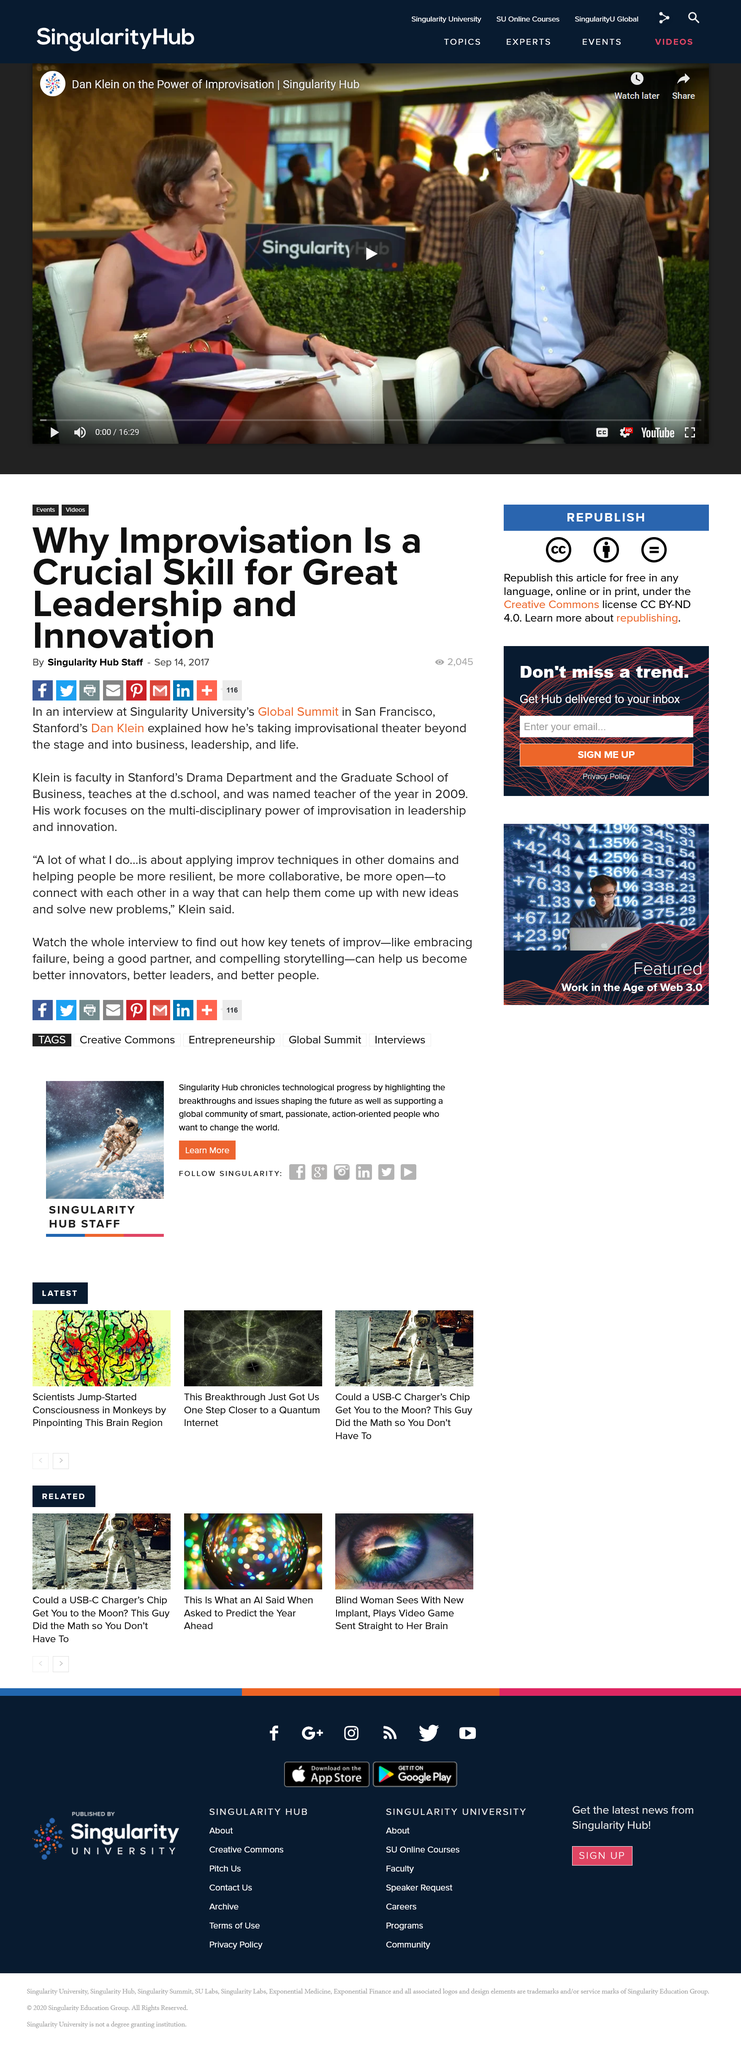Specify some key components in this picture. Dan Klein works in both the Drama Department and the Graduate School of Business at Stanford University. The Singularity University's Global Summit was held in San Francisco. The article was written on 14th September 2017, as stated in the article. 